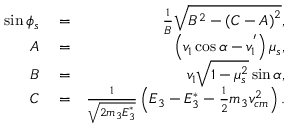<formula> <loc_0><loc_0><loc_500><loc_500>\begin{array} { r l r } { \sin \phi _ { s } } & = } & { \frac { 1 } { B } \sqrt { B ^ { 2 } - \left ( C - A \right ) ^ { 2 } } , } \\ { A } & = } & { \left ( v _ { 1 } \cos \alpha - v _ { 1 } ^ { ^ { \prime } } \right ) \mu _ { s } , } \\ { B } & = } & { v _ { 1 } \sqrt { 1 - \mu _ { s } ^ { 2 } } \sin \alpha , } \\ { C } & = } & { \frac { 1 } { \sqrt { 2 m _ { 3 } E _ { 3 } ^ { * } } } \left ( E _ { 3 } - E _ { 3 } ^ { * } - \frac { 1 } { 2 } m _ { 3 } v _ { c m } ^ { 2 } \right ) . } \end{array}</formula> 